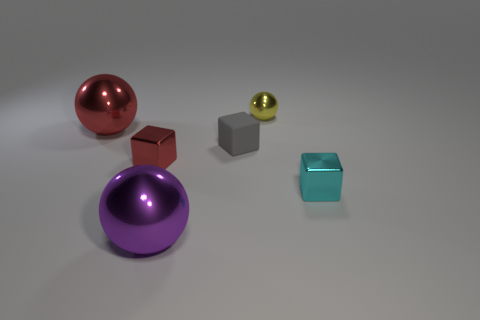How big is the object that is behind the gray rubber cube and to the left of the purple thing?
Provide a short and direct response. Large. What number of big purple objects have the same material as the tiny cyan thing?
Offer a very short reply. 1. What is the color of the small rubber object?
Give a very brief answer. Gray. Do the red thing that is on the left side of the red cube and the small cyan thing have the same shape?
Your answer should be very brief. No. How many objects are red objects to the right of the red shiny ball or small cyan metallic spheres?
Make the answer very short. 1. Are there any other shiny things of the same shape as the tiny cyan thing?
Offer a very short reply. Yes. What is the shape of the cyan metal object that is the same size as the red cube?
Provide a short and direct response. Cube. The small metal object behind the rubber block that is on the left side of the shiny sphere that is behind the red shiny sphere is what shape?
Offer a terse response. Sphere. There is a tiny cyan shiny object; does it have the same shape as the tiny object behind the tiny rubber thing?
Provide a succinct answer. No. How many big objects are cyan metallic cylinders or gray matte blocks?
Provide a short and direct response. 0. 